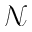Convert formula to latex. <formula><loc_0><loc_0><loc_500><loc_500>\mathcal { N }</formula> 